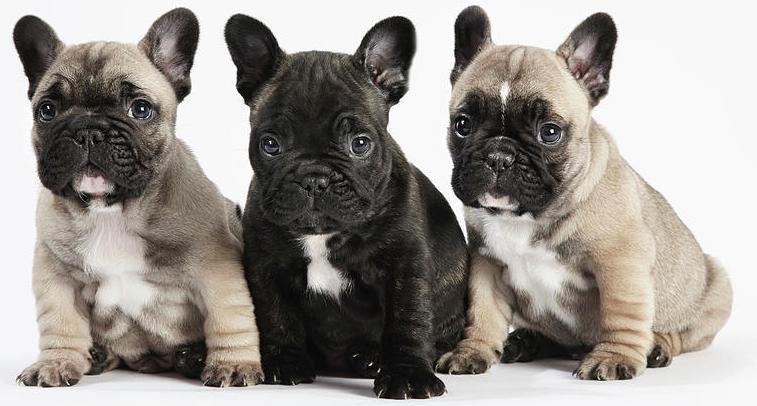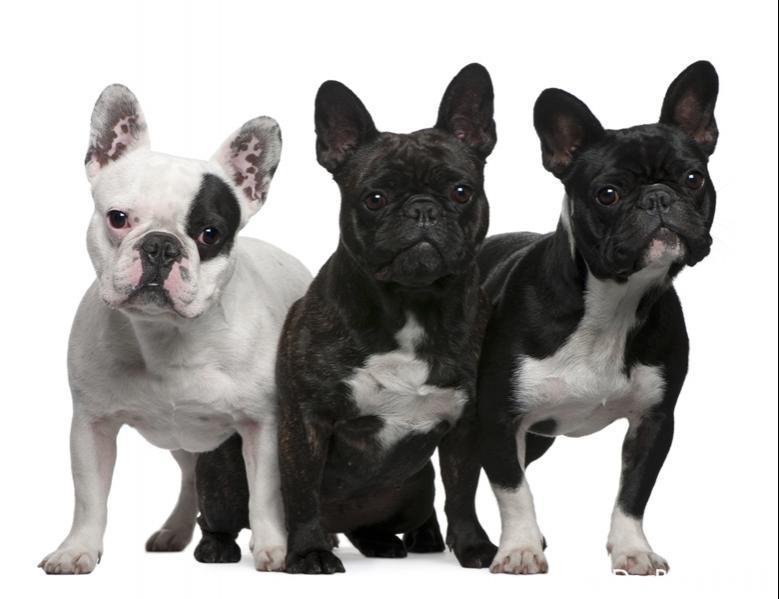The first image is the image on the left, the second image is the image on the right. Evaluate the accuracy of this statement regarding the images: "There is atleast one white, pied french bulldog.". Is it true? Answer yes or no. Yes. The first image is the image on the left, the second image is the image on the right. Evaluate the accuracy of this statement regarding the images: "At least one dog is wearing a red collar.". Is it true? Answer yes or no. No. 